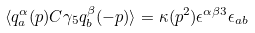Convert formula to latex. <formula><loc_0><loc_0><loc_500><loc_500>\langle q ^ { \alpha } _ { a } ( p ) C \gamma _ { 5 } q ^ { \beta } _ { b } ( - p ) \rangle = \kappa ( p ^ { 2 } ) \epsilon ^ { \alpha \beta 3 } \epsilon _ { a b }</formula> 